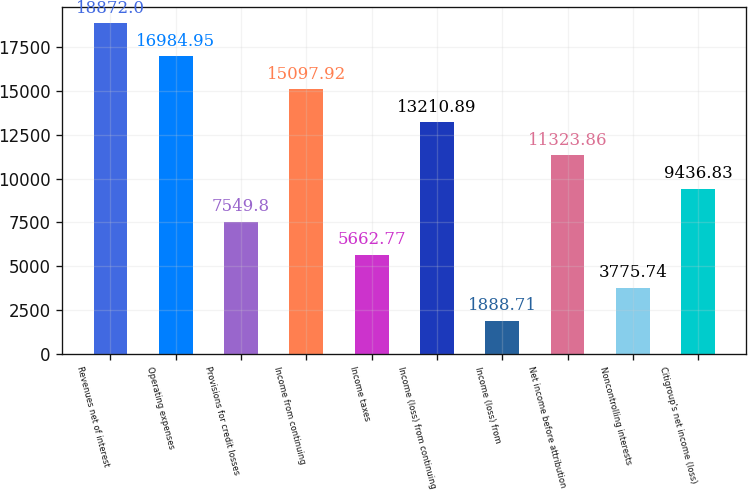Convert chart to OTSL. <chart><loc_0><loc_0><loc_500><loc_500><bar_chart><fcel>Revenues net of interest<fcel>Operating expenses<fcel>Provisions for credit losses<fcel>Income from continuing<fcel>Income taxes<fcel>Income (loss) from continuing<fcel>Income (loss) from<fcel>Net income before attribution<fcel>Noncontrolling interests<fcel>Citigroup's net income (loss)<nl><fcel>18872<fcel>16985<fcel>7549.8<fcel>15097.9<fcel>5662.77<fcel>13210.9<fcel>1888.71<fcel>11323.9<fcel>3775.74<fcel>9436.83<nl></chart> 